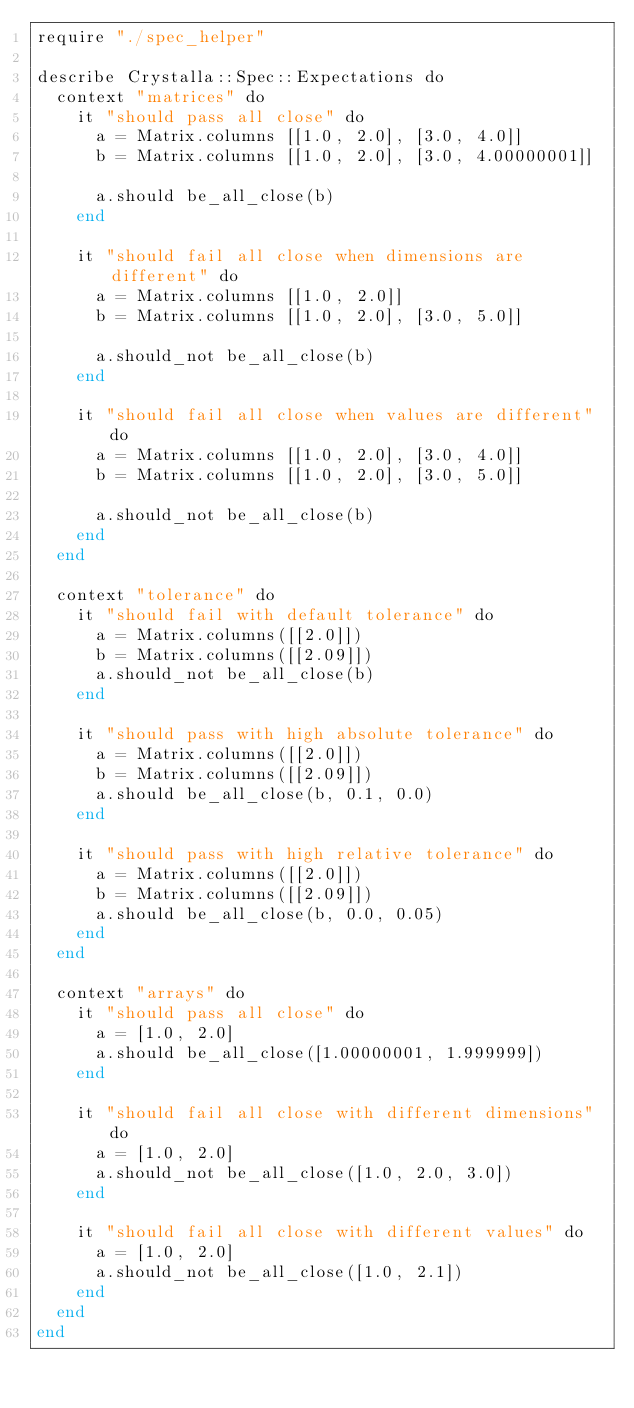Convert code to text. <code><loc_0><loc_0><loc_500><loc_500><_Crystal_>require "./spec_helper"

describe Crystalla::Spec::Expectations do
  context "matrices" do
    it "should pass all close" do
      a = Matrix.columns [[1.0, 2.0], [3.0, 4.0]]
      b = Matrix.columns [[1.0, 2.0], [3.0, 4.00000001]]

      a.should be_all_close(b)
    end

    it "should fail all close when dimensions are different" do
      a = Matrix.columns [[1.0, 2.0]]
      b = Matrix.columns [[1.0, 2.0], [3.0, 5.0]]

      a.should_not be_all_close(b)
    end

    it "should fail all close when values are different" do
      a = Matrix.columns [[1.0, 2.0], [3.0, 4.0]]
      b = Matrix.columns [[1.0, 2.0], [3.0, 5.0]]

      a.should_not be_all_close(b)
    end
  end

  context "tolerance" do
    it "should fail with default tolerance" do
      a = Matrix.columns([[2.0]])
      b = Matrix.columns([[2.09]])
      a.should_not be_all_close(b)
    end

    it "should pass with high absolute tolerance" do
      a = Matrix.columns([[2.0]])
      b = Matrix.columns([[2.09]])
      a.should be_all_close(b, 0.1, 0.0)
    end

    it "should pass with high relative tolerance" do
      a = Matrix.columns([[2.0]])
      b = Matrix.columns([[2.09]])
      a.should be_all_close(b, 0.0, 0.05)
    end
  end

  context "arrays" do
    it "should pass all close" do
      a = [1.0, 2.0]
      a.should be_all_close([1.00000001, 1.999999])
    end

    it "should fail all close with different dimensions" do
      a = [1.0, 2.0]
      a.should_not be_all_close([1.0, 2.0, 3.0])
    end

    it "should fail all close with different values" do
      a = [1.0, 2.0]
      a.should_not be_all_close([1.0, 2.1])
    end
  end
end
</code> 